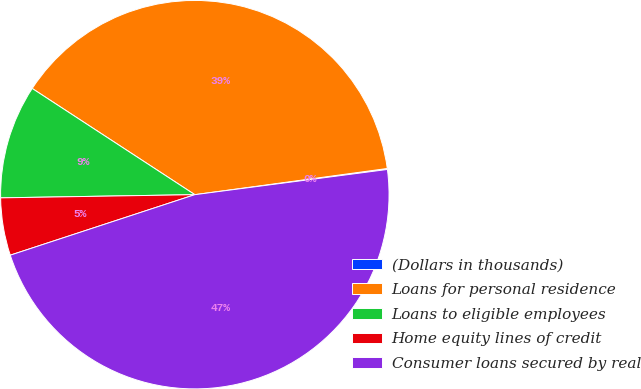Convert chart to OTSL. <chart><loc_0><loc_0><loc_500><loc_500><pie_chart><fcel>(Dollars in thousands)<fcel>Loans for personal residence<fcel>Loans to eligible employees<fcel>Home equity lines of credit<fcel>Consumer loans secured by real<nl><fcel>0.08%<fcel>38.64%<fcel>9.47%<fcel>4.78%<fcel>47.03%<nl></chart> 